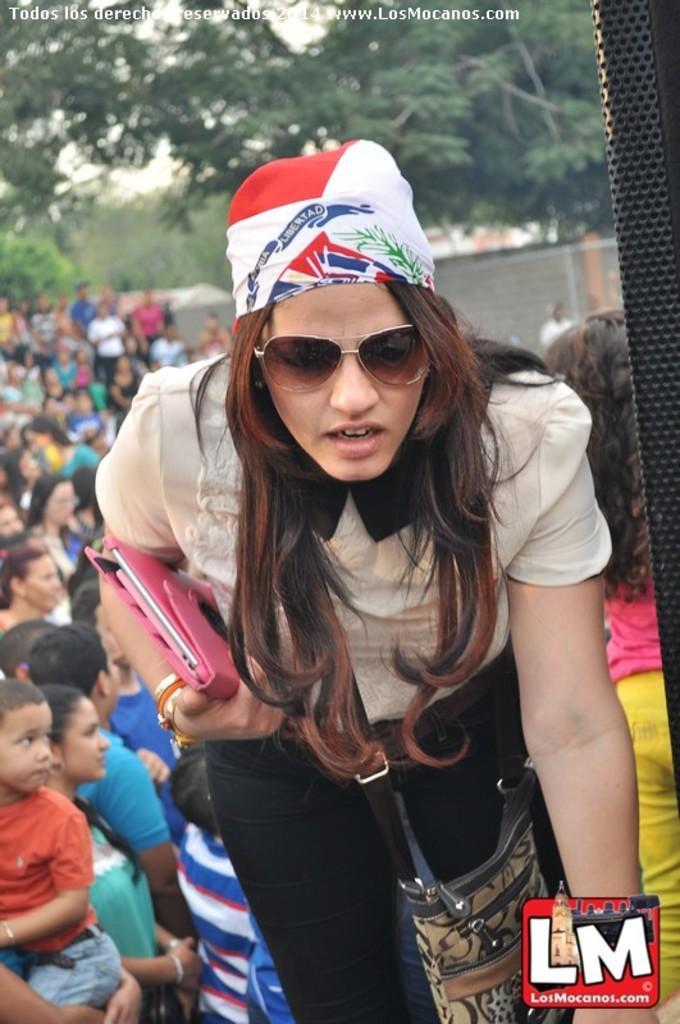Can you describe this image briefly? In this image we can see a woman wearing dress, glasses, headwear and handbag is holding a pink color object in her hands. In the background, we can see a few more people, the wall and trees. Here we can see the logo on the bottom right of the image and at the top left side of the image we can see the watermark. 